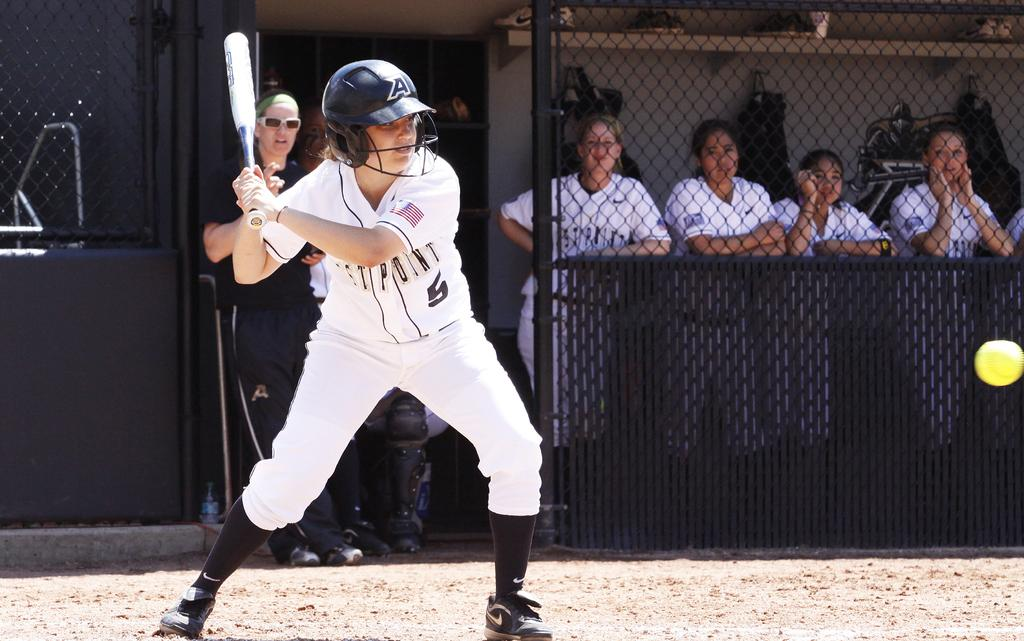<image>
Provide a brief description of the given image. A girl swings a bat at a softball while wearing a West Point jersey. 